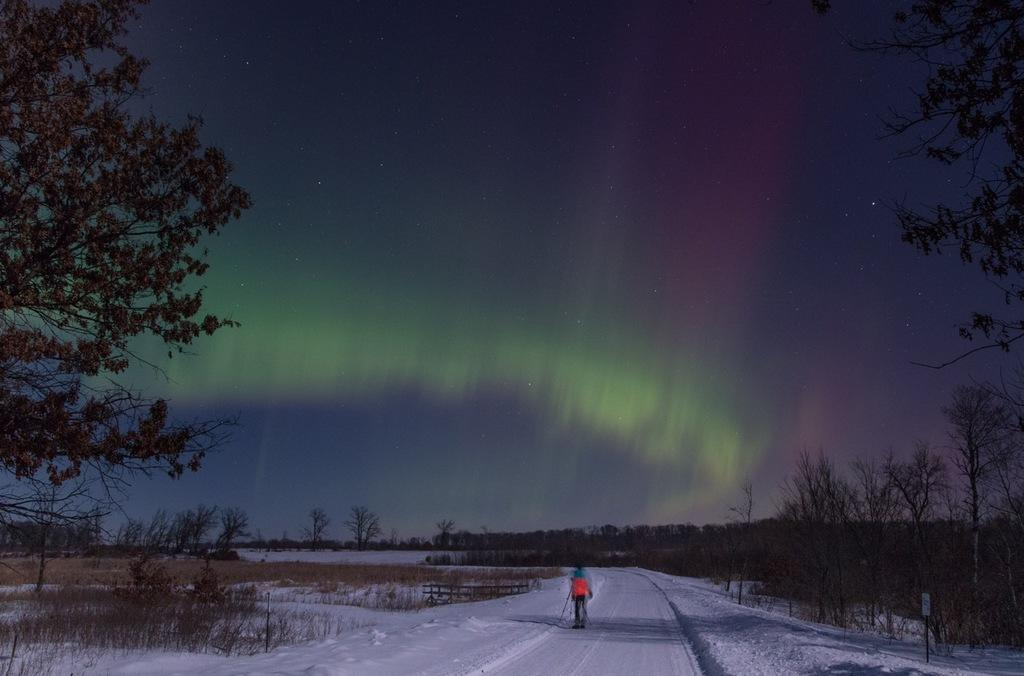Who or what is present in the image? There is a person in the image. What is the ground covered with in the image? The ground has snow in the image. What type of vegetation can be seen in the image? There are trees and plants in the image. What part of the natural environment is visible in the image? The sky is visible in the image. What type of flowers are being served at the event in the image? There is no event or flowers present in the image; it features a person in a snowy environment with trees and plants. 